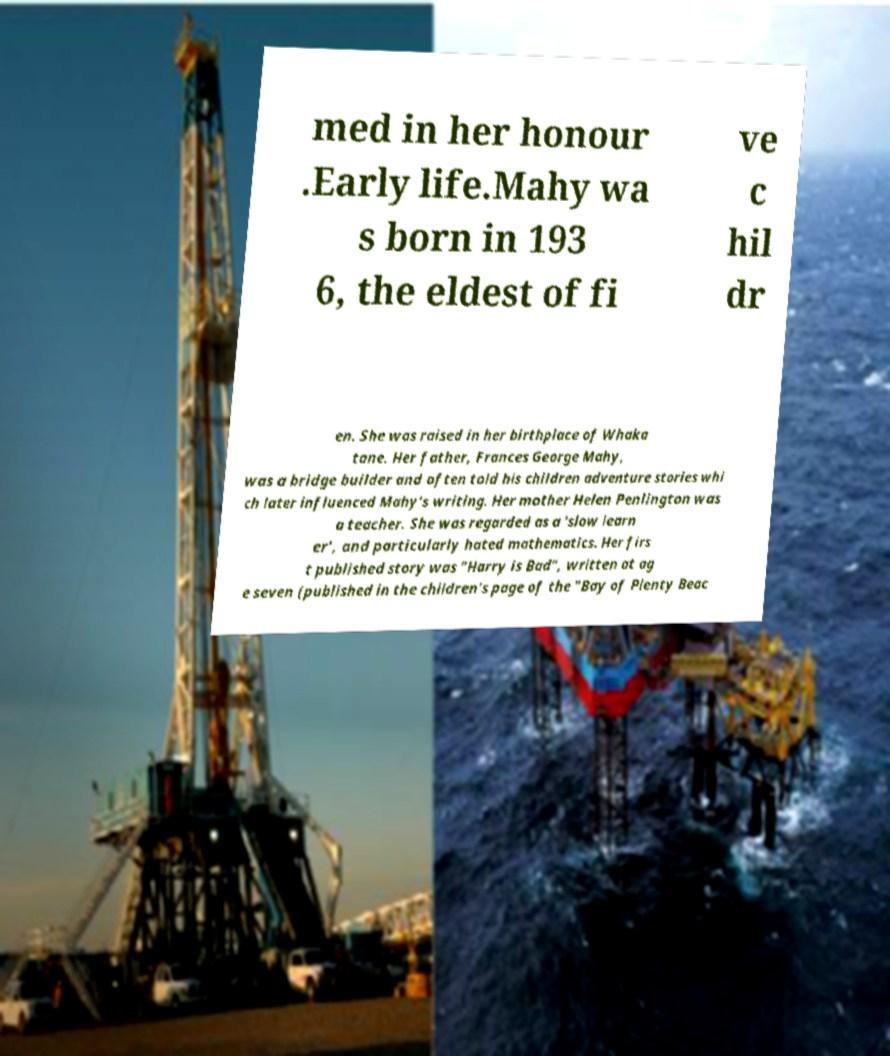Can you read and provide the text displayed in the image?This photo seems to have some interesting text. Can you extract and type it out for me? med in her honour .Early life.Mahy wa s born in 193 6, the eldest of fi ve c hil dr en. She was raised in her birthplace of Whaka tane. Her father, Frances George Mahy, was a bridge builder and often told his children adventure stories whi ch later influenced Mahy's writing. Her mother Helen Penlington was a teacher. She was regarded as a 'slow learn er', and particularly hated mathematics. Her firs t published story was "Harry is Bad", written at ag e seven (published in the children's page of the "Bay of Plenty Beac 